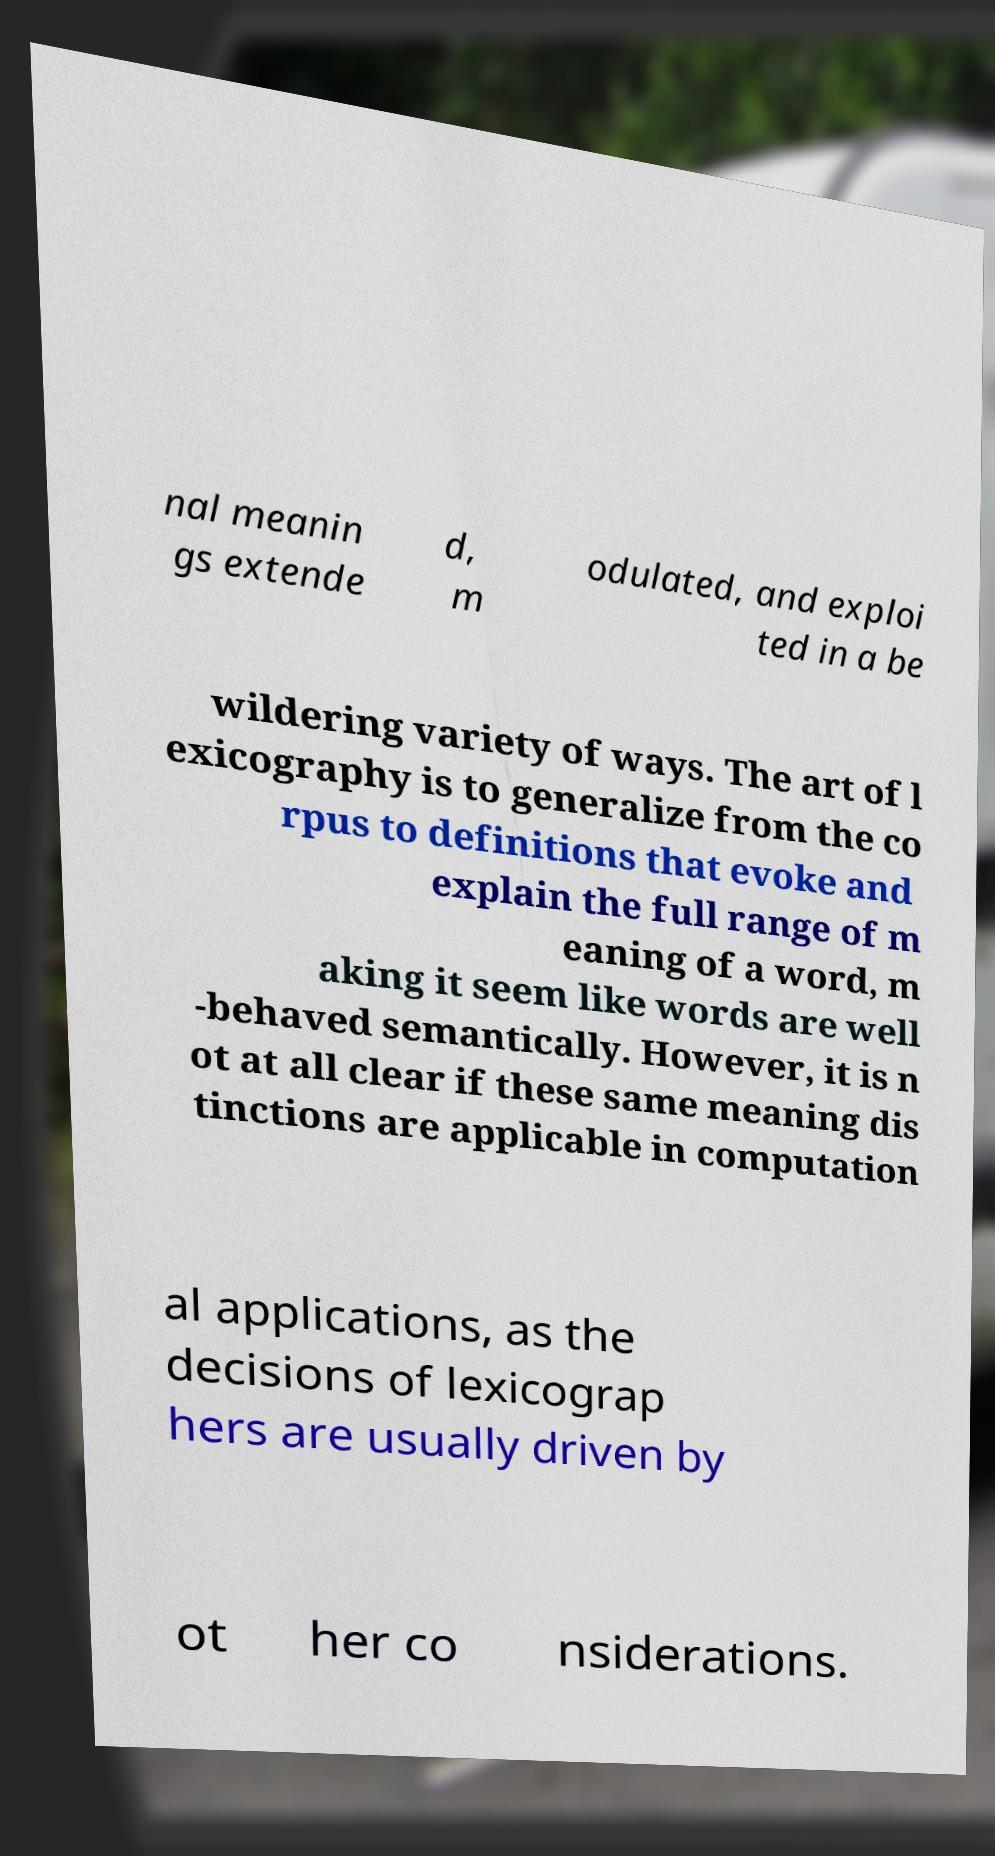Could you assist in decoding the text presented in this image and type it out clearly? nal meanin gs extende d, m odulated, and exploi ted in a be wildering variety of ways. The art of l exicography is to generalize from the co rpus to definitions that evoke and explain the full range of m eaning of a word, m aking it seem like words are well -behaved semantically. However, it is n ot at all clear if these same meaning dis tinctions are applicable in computation al applications, as the decisions of lexicograp hers are usually driven by ot her co nsiderations. 